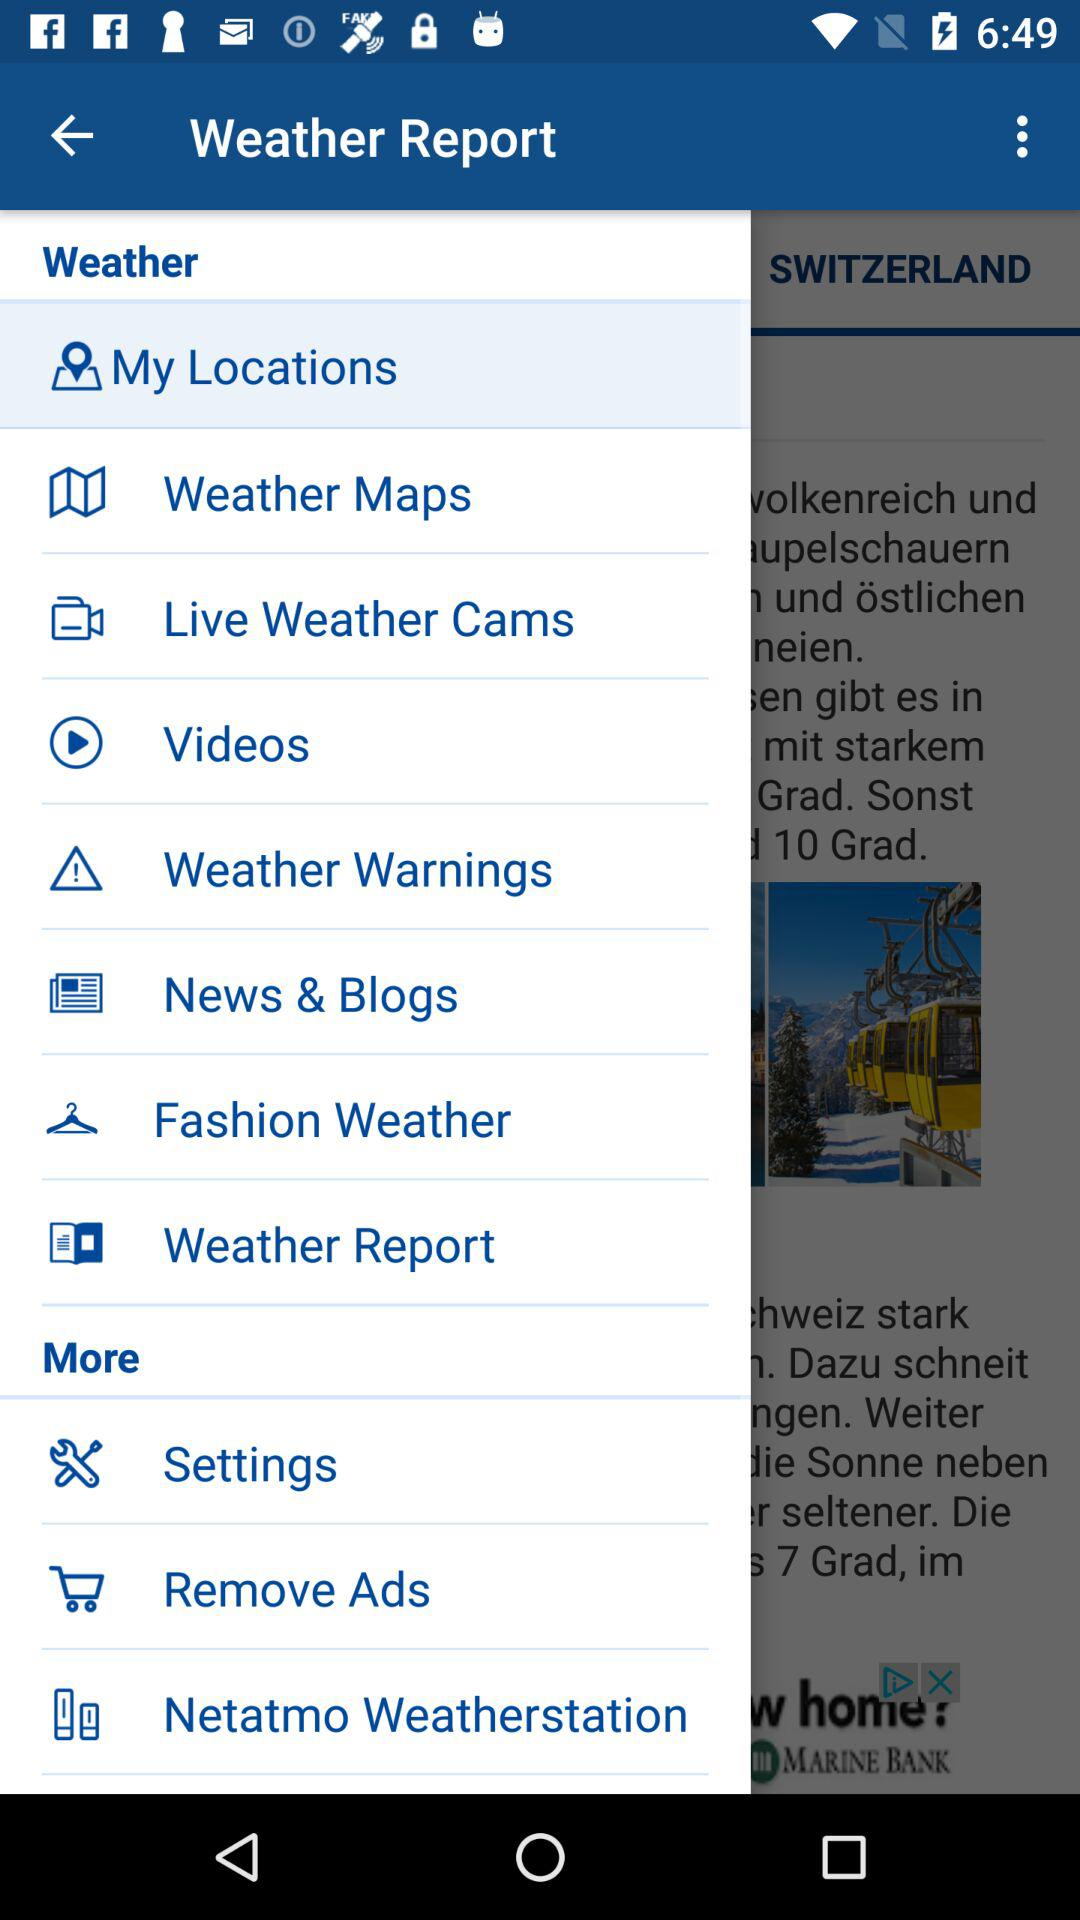Which item is selected? The selected item is "My Locations". 